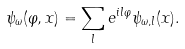<formula> <loc_0><loc_0><loc_500><loc_500>\psi _ { \omega } ( \varphi , { x } ) = \sum _ { l } e ^ { i l \varphi } \psi _ { \omega , l } ( { x } ) .</formula> 